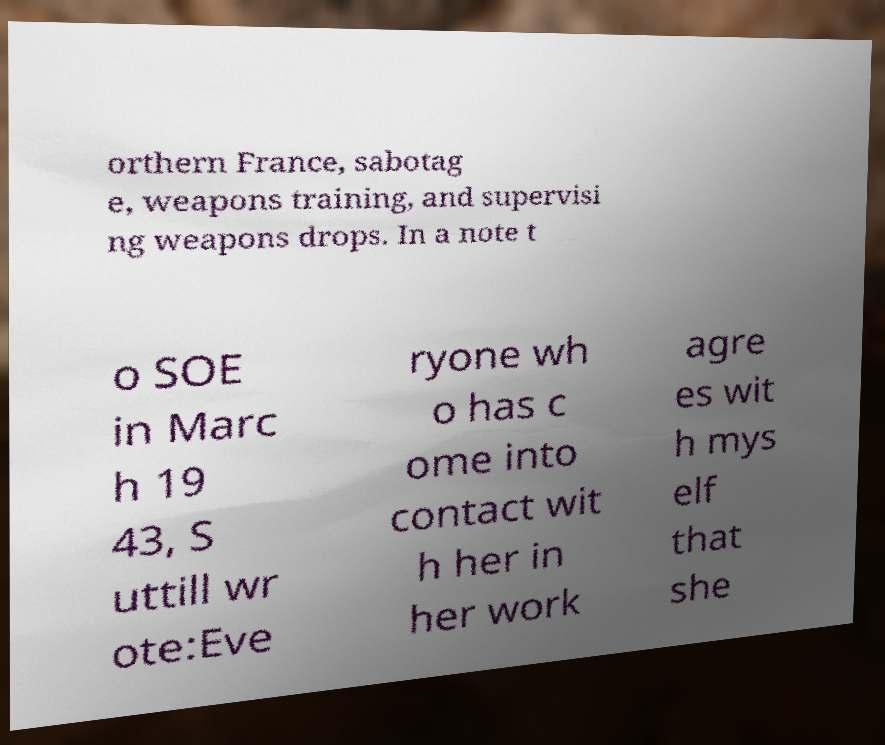For documentation purposes, I need the text within this image transcribed. Could you provide that? orthern France, sabotag e, weapons training, and supervisi ng weapons drops. In a note t o SOE in Marc h 19 43, S uttill wr ote:Eve ryone wh o has c ome into contact wit h her in her work agre es wit h mys elf that she 